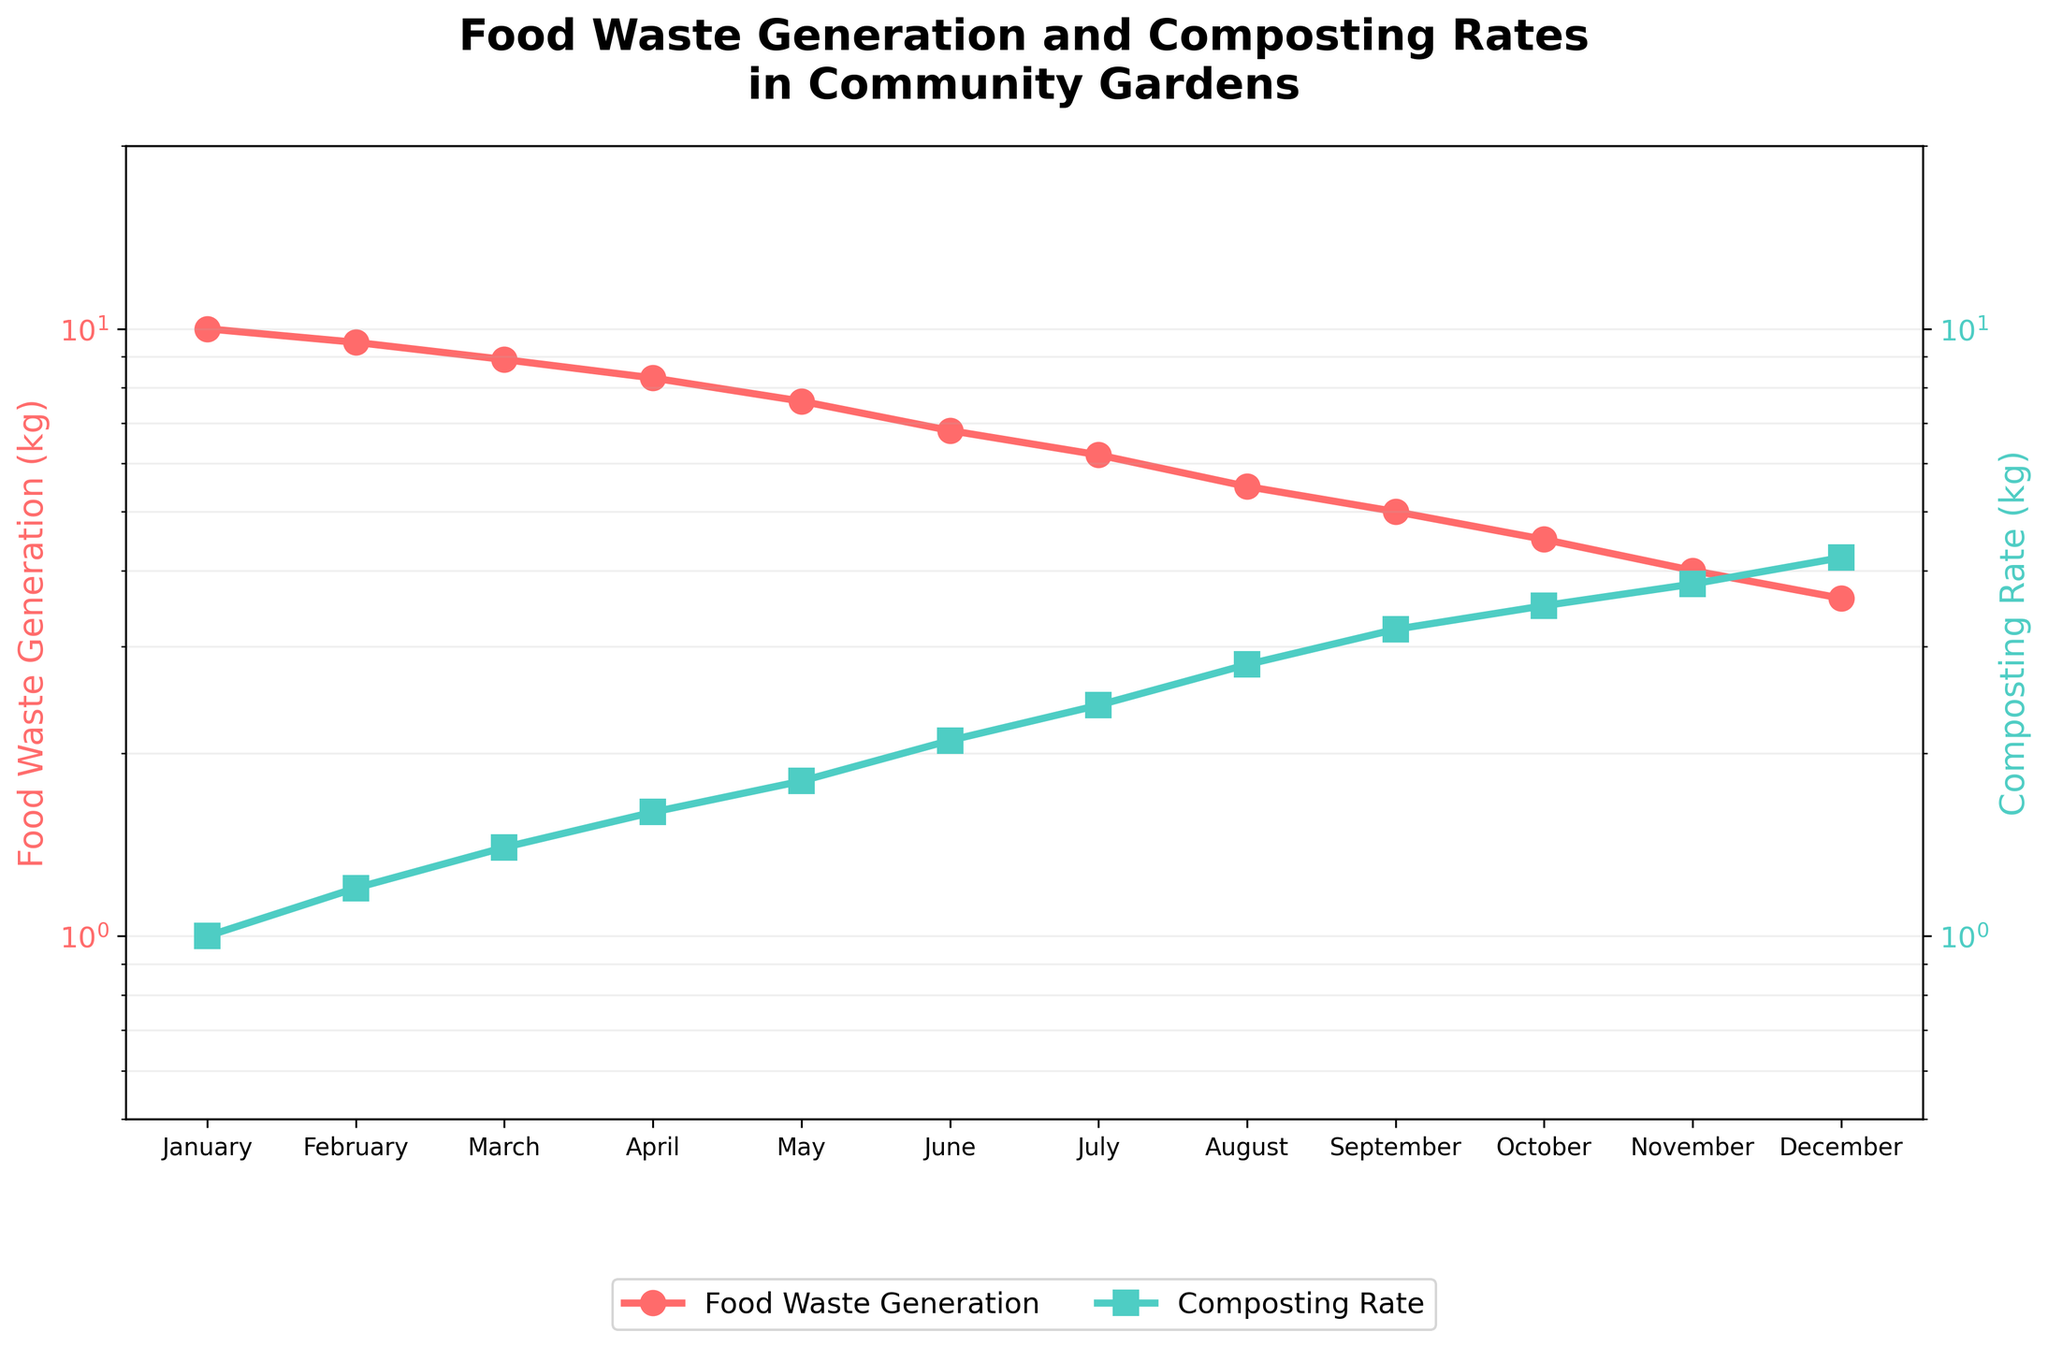What is the title of the figure? The title of the figure is displayed prominently at the top of the chart.
Answer: Food Waste Generation and Composting Rates in Community Gardens How many months are represented in the figure? The x-axis labels indicate each month. Counting these labels will give us the total number of months represented.
Answer: 12 What color represents the Food Waste Generation line? The Food Waste Generation line is visually distinct due to its color.
Answer: Red What is the Food Waste Generation in August? Locate the August point on the x-axis and trace up to the corresponding point on the Food Waste Generation curve.
Answer: 5.5 kg What is the Composting Rate in December? Locate the December point on the x-axis and trace up to the corresponding point on the Composting Rate curve.
Answer: 4.2 kg How does the Food Waste Generation change from January to December? Compare the values at the start and end of the Food Waste Generation curve to understand its overall trend.
Answer: It decreases from 10.0 kg to 3.6 kg Which month has the highest Composting Rate? Identify the maximum point on the Composting Rate curve and note which month it corresponds to.
Answer: December In which month do the Food Waste Generation and Composting Rates intersect, if at all? Look for a point where the Food Waste Generation and Composting Rates curves cross each other.
Answer: They do not intersect What is the average Food Waste Generation over the year? Sum all the Food Waste Generation values and divide by the number of months. (10.0 + 9.5 + 8.9 + 8.3 + 7.6 + 6.8 + 6.2 + 5.5 + 5.0 + 4.5 + 4.0 + 3.6) / 12
Answer: 6.65 kg What trend do you observe in the Composting Rate from January to December? Examine the Composting Rate curve from start to end to describe its overall direction.
Answer: It increases from 1.0 kg to 4.2 kg 